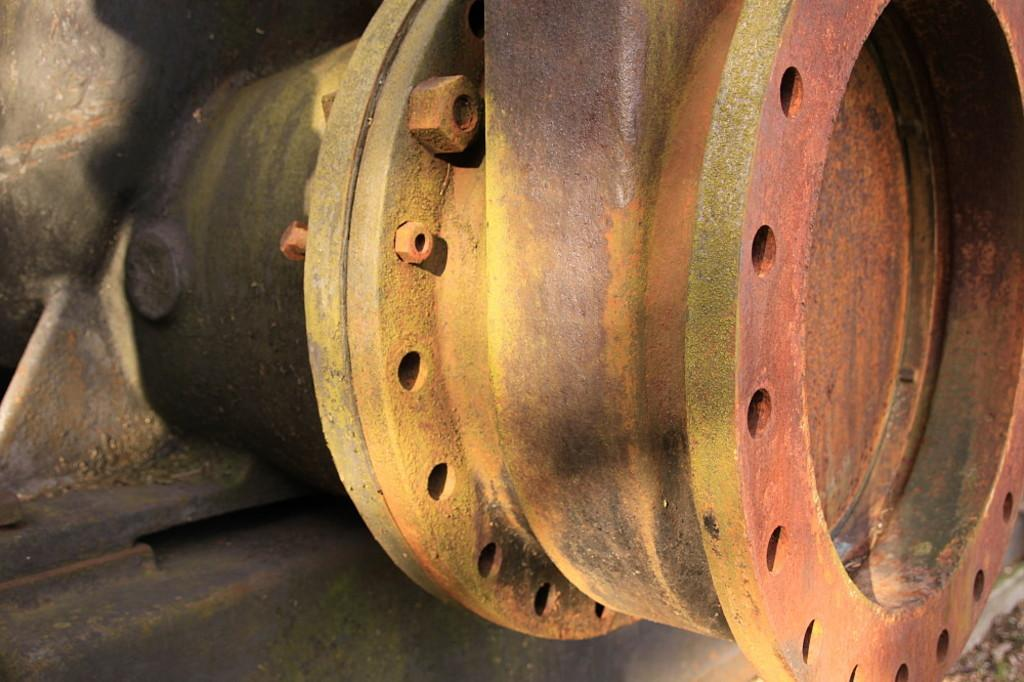What type of material is used for the rods in the image? The metal rods in the image are made of metal. What other object can be seen in the image besides the metal rods? There is a wheel in the image. What type of bone is visible in the image? There is no bone present in the image; it features metal rods and a wheel. What type of cloth is draped over the wheel in the image? There is no cloth present in the image; it only features metal rods and a wheel. 